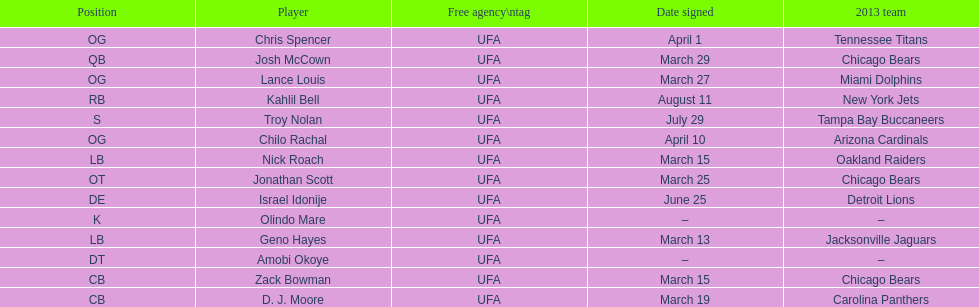How many players play cb or og? 5. 